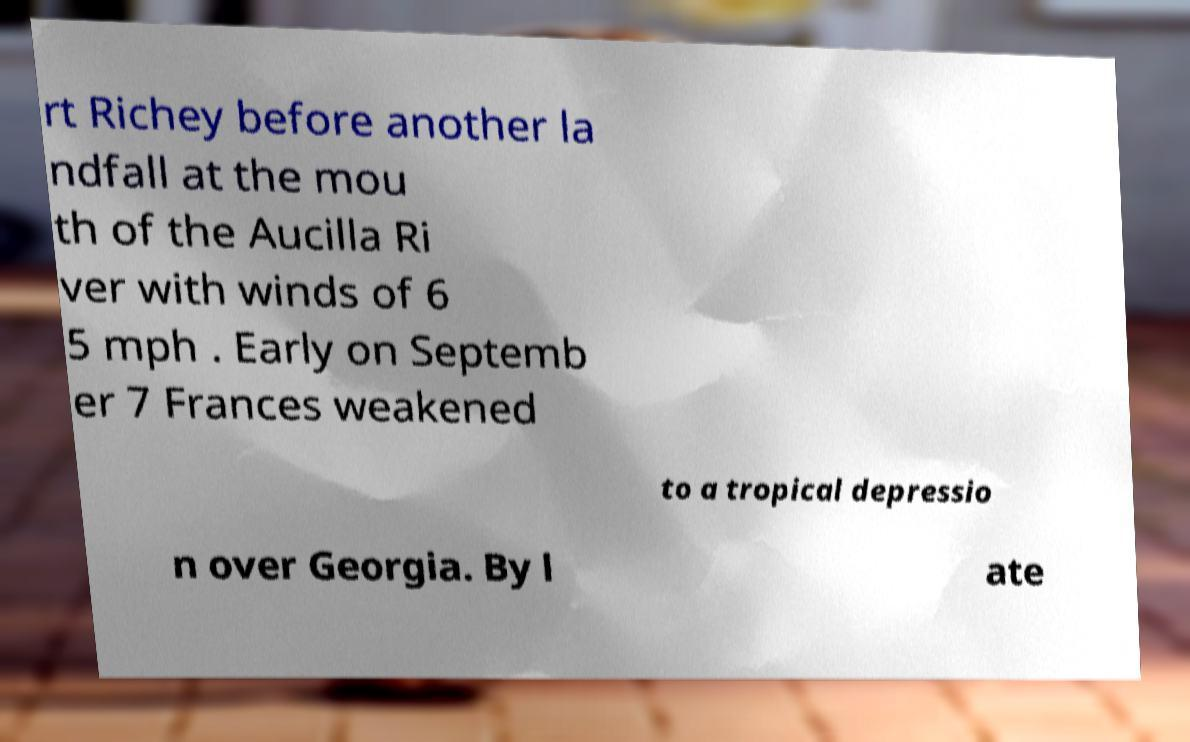Can you read and provide the text displayed in the image?This photo seems to have some interesting text. Can you extract and type it out for me? rt Richey before another la ndfall at the mou th of the Aucilla Ri ver with winds of 6 5 mph . Early on Septemb er 7 Frances weakened to a tropical depressio n over Georgia. By l ate 